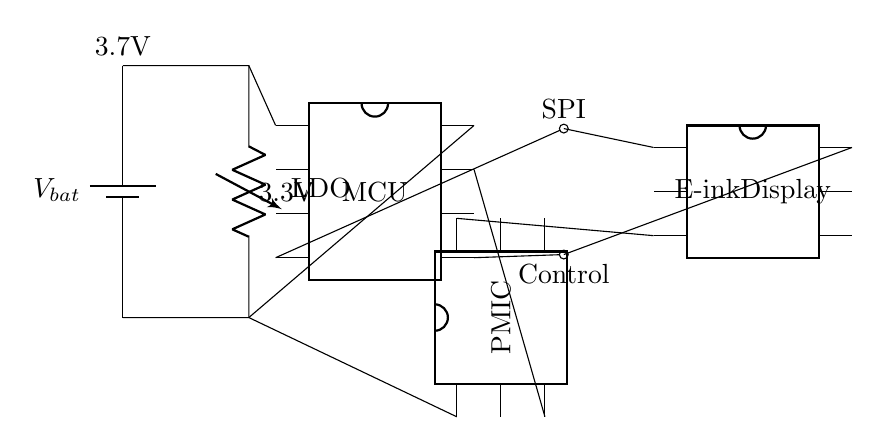What is the primary power supply voltage? The primary power supply voltage is indicated by the battery symbol at the top left of the circuit diagram, which shows 3.7 volts.
Answer: 3.7V What component regulates the voltage? The component that regulates the voltage is labeled as LDO, which stands for Low Dropout Regulator, shown in the middle of the circuit diagram. This component ensures that the voltage supplied to the microcontroller is stable at a lower voltage.
Answer: LDO Which device is connected to the e-ink display? The device connected to the e-ink display is the microcontroller, as it provides control signals and communicates with the display, seen connected via the control and SPI lines.
Answer: Microcontroller What connection does the microcontroller use to communicate with the display? The microcontroller uses the SPI (Serial Peripheral Interface) for communication with the display, noted by the label SPI connecting the microcontroller and the e-ink display in the diagram.
Answer: SPI What voltage does the microcontroller operate at? The microcontroller operates at 3.3 volts, which is indicated by the label next to the LDO; this is the regulated voltage output from the voltage regulator.
Answer: 3.3V How many pins does the power management IC have? The power management IC has six pins, as indicated by the pin count displayed next to the PMIC symbol in the diagram.
Answer: Six pins Which component provides power to the display? The component that provides power to the display is the power management IC, which offers the necessary voltage connections from the battery to the display indicated in the circuit.
Answer: PMIC 